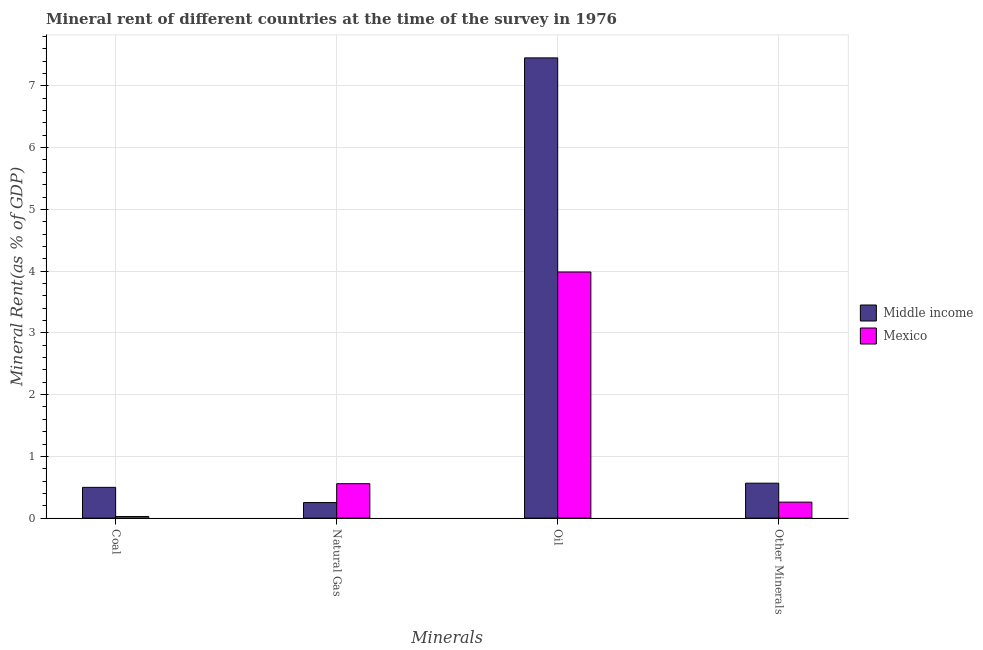How many different coloured bars are there?
Give a very brief answer. 2. Are the number of bars on each tick of the X-axis equal?
Keep it short and to the point. Yes. How many bars are there on the 1st tick from the right?
Offer a very short reply. 2. What is the label of the 4th group of bars from the left?
Your answer should be very brief. Other Minerals. What is the  rent of other minerals in Middle income?
Keep it short and to the point. 0.57. Across all countries, what is the maximum  rent of other minerals?
Keep it short and to the point. 0.57. Across all countries, what is the minimum coal rent?
Your answer should be very brief. 0.03. What is the total coal rent in the graph?
Provide a short and direct response. 0.52. What is the difference between the  rent of other minerals in Mexico and that in Middle income?
Make the answer very short. -0.31. What is the difference between the  rent of other minerals in Mexico and the coal rent in Middle income?
Offer a very short reply. -0.24. What is the average natural gas rent per country?
Make the answer very short. 0.4. What is the difference between the coal rent and natural gas rent in Middle income?
Give a very brief answer. 0.25. In how many countries, is the  rent of other minerals greater than 7 %?
Your answer should be very brief. 0. What is the ratio of the  rent of other minerals in Mexico to that in Middle income?
Your answer should be very brief. 0.46. Is the  rent of other minerals in Mexico less than that in Middle income?
Give a very brief answer. Yes. What is the difference between the highest and the second highest  rent of other minerals?
Make the answer very short. 0.31. What is the difference between the highest and the lowest  rent of other minerals?
Your answer should be very brief. 0.31. In how many countries, is the natural gas rent greater than the average natural gas rent taken over all countries?
Ensure brevity in your answer.  1. Is the sum of the coal rent in Middle income and Mexico greater than the maximum oil rent across all countries?
Your answer should be very brief. No. What does the 2nd bar from the left in Coal represents?
Keep it short and to the point. Mexico. What does the 2nd bar from the right in Oil represents?
Your response must be concise. Middle income. Are all the bars in the graph horizontal?
Give a very brief answer. No. Does the graph contain grids?
Offer a terse response. Yes. Where does the legend appear in the graph?
Your response must be concise. Center right. How are the legend labels stacked?
Your answer should be compact. Vertical. What is the title of the graph?
Ensure brevity in your answer.  Mineral rent of different countries at the time of the survey in 1976. Does "South Asia" appear as one of the legend labels in the graph?
Offer a very short reply. No. What is the label or title of the X-axis?
Your response must be concise. Minerals. What is the label or title of the Y-axis?
Ensure brevity in your answer.  Mineral Rent(as % of GDP). What is the Mineral Rent(as % of GDP) of Middle income in Coal?
Offer a terse response. 0.5. What is the Mineral Rent(as % of GDP) of Mexico in Coal?
Provide a succinct answer. 0.03. What is the Mineral Rent(as % of GDP) of Middle income in Natural Gas?
Your response must be concise. 0.25. What is the Mineral Rent(as % of GDP) of Mexico in Natural Gas?
Your answer should be compact. 0.56. What is the Mineral Rent(as % of GDP) in Middle income in Oil?
Provide a succinct answer. 7.45. What is the Mineral Rent(as % of GDP) in Mexico in Oil?
Make the answer very short. 3.99. What is the Mineral Rent(as % of GDP) in Middle income in Other Minerals?
Offer a very short reply. 0.57. What is the Mineral Rent(as % of GDP) in Mexico in Other Minerals?
Your answer should be compact. 0.26. Across all Minerals, what is the maximum Mineral Rent(as % of GDP) of Middle income?
Offer a very short reply. 7.45. Across all Minerals, what is the maximum Mineral Rent(as % of GDP) of Mexico?
Your response must be concise. 3.99. Across all Minerals, what is the minimum Mineral Rent(as % of GDP) in Middle income?
Provide a short and direct response. 0.25. Across all Minerals, what is the minimum Mineral Rent(as % of GDP) in Mexico?
Your answer should be very brief. 0.03. What is the total Mineral Rent(as % of GDP) of Middle income in the graph?
Keep it short and to the point. 8.77. What is the total Mineral Rent(as % of GDP) of Mexico in the graph?
Your answer should be very brief. 4.83. What is the difference between the Mineral Rent(as % of GDP) in Middle income in Coal and that in Natural Gas?
Keep it short and to the point. 0.25. What is the difference between the Mineral Rent(as % of GDP) of Mexico in Coal and that in Natural Gas?
Make the answer very short. -0.53. What is the difference between the Mineral Rent(as % of GDP) of Middle income in Coal and that in Oil?
Ensure brevity in your answer.  -6.96. What is the difference between the Mineral Rent(as % of GDP) of Mexico in Coal and that in Oil?
Provide a short and direct response. -3.96. What is the difference between the Mineral Rent(as % of GDP) in Middle income in Coal and that in Other Minerals?
Make the answer very short. -0.07. What is the difference between the Mineral Rent(as % of GDP) in Mexico in Coal and that in Other Minerals?
Make the answer very short. -0.23. What is the difference between the Mineral Rent(as % of GDP) of Middle income in Natural Gas and that in Oil?
Make the answer very short. -7.2. What is the difference between the Mineral Rent(as % of GDP) in Mexico in Natural Gas and that in Oil?
Your answer should be compact. -3.43. What is the difference between the Mineral Rent(as % of GDP) of Middle income in Natural Gas and that in Other Minerals?
Make the answer very short. -0.31. What is the difference between the Mineral Rent(as % of GDP) in Mexico in Natural Gas and that in Other Minerals?
Provide a short and direct response. 0.3. What is the difference between the Mineral Rent(as % of GDP) of Middle income in Oil and that in Other Minerals?
Provide a short and direct response. 6.89. What is the difference between the Mineral Rent(as % of GDP) in Mexico in Oil and that in Other Minerals?
Ensure brevity in your answer.  3.73. What is the difference between the Mineral Rent(as % of GDP) of Middle income in Coal and the Mineral Rent(as % of GDP) of Mexico in Natural Gas?
Ensure brevity in your answer.  -0.06. What is the difference between the Mineral Rent(as % of GDP) in Middle income in Coal and the Mineral Rent(as % of GDP) in Mexico in Oil?
Your response must be concise. -3.49. What is the difference between the Mineral Rent(as % of GDP) of Middle income in Coal and the Mineral Rent(as % of GDP) of Mexico in Other Minerals?
Provide a short and direct response. 0.24. What is the difference between the Mineral Rent(as % of GDP) of Middle income in Natural Gas and the Mineral Rent(as % of GDP) of Mexico in Oil?
Ensure brevity in your answer.  -3.73. What is the difference between the Mineral Rent(as % of GDP) in Middle income in Natural Gas and the Mineral Rent(as % of GDP) in Mexico in Other Minerals?
Ensure brevity in your answer.  -0.01. What is the difference between the Mineral Rent(as % of GDP) of Middle income in Oil and the Mineral Rent(as % of GDP) of Mexico in Other Minerals?
Your response must be concise. 7.19. What is the average Mineral Rent(as % of GDP) of Middle income per Minerals?
Offer a very short reply. 2.19. What is the average Mineral Rent(as % of GDP) of Mexico per Minerals?
Your answer should be very brief. 1.21. What is the difference between the Mineral Rent(as % of GDP) of Middle income and Mineral Rent(as % of GDP) of Mexico in Coal?
Your answer should be compact. 0.47. What is the difference between the Mineral Rent(as % of GDP) of Middle income and Mineral Rent(as % of GDP) of Mexico in Natural Gas?
Offer a terse response. -0.31. What is the difference between the Mineral Rent(as % of GDP) of Middle income and Mineral Rent(as % of GDP) of Mexico in Oil?
Ensure brevity in your answer.  3.47. What is the difference between the Mineral Rent(as % of GDP) of Middle income and Mineral Rent(as % of GDP) of Mexico in Other Minerals?
Keep it short and to the point. 0.31. What is the ratio of the Mineral Rent(as % of GDP) of Middle income in Coal to that in Natural Gas?
Make the answer very short. 1.98. What is the ratio of the Mineral Rent(as % of GDP) in Mexico in Coal to that in Natural Gas?
Offer a terse response. 0.05. What is the ratio of the Mineral Rent(as % of GDP) of Middle income in Coal to that in Oil?
Your response must be concise. 0.07. What is the ratio of the Mineral Rent(as % of GDP) in Mexico in Coal to that in Oil?
Make the answer very short. 0.01. What is the ratio of the Mineral Rent(as % of GDP) of Middle income in Coal to that in Other Minerals?
Your answer should be very brief. 0.88. What is the ratio of the Mineral Rent(as % of GDP) in Mexico in Coal to that in Other Minerals?
Provide a succinct answer. 0.1. What is the ratio of the Mineral Rent(as % of GDP) of Middle income in Natural Gas to that in Oil?
Provide a short and direct response. 0.03. What is the ratio of the Mineral Rent(as % of GDP) in Mexico in Natural Gas to that in Oil?
Offer a terse response. 0.14. What is the ratio of the Mineral Rent(as % of GDP) of Middle income in Natural Gas to that in Other Minerals?
Offer a terse response. 0.45. What is the ratio of the Mineral Rent(as % of GDP) in Mexico in Natural Gas to that in Other Minerals?
Keep it short and to the point. 2.15. What is the ratio of the Mineral Rent(as % of GDP) of Middle income in Oil to that in Other Minerals?
Your answer should be very brief. 13.17. What is the ratio of the Mineral Rent(as % of GDP) of Mexico in Oil to that in Other Minerals?
Offer a terse response. 15.4. What is the difference between the highest and the second highest Mineral Rent(as % of GDP) in Middle income?
Your answer should be compact. 6.89. What is the difference between the highest and the second highest Mineral Rent(as % of GDP) in Mexico?
Keep it short and to the point. 3.43. What is the difference between the highest and the lowest Mineral Rent(as % of GDP) in Middle income?
Make the answer very short. 7.2. What is the difference between the highest and the lowest Mineral Rent(as % of GDP) in Mexico?
Offer a very short reply. 3.96. 